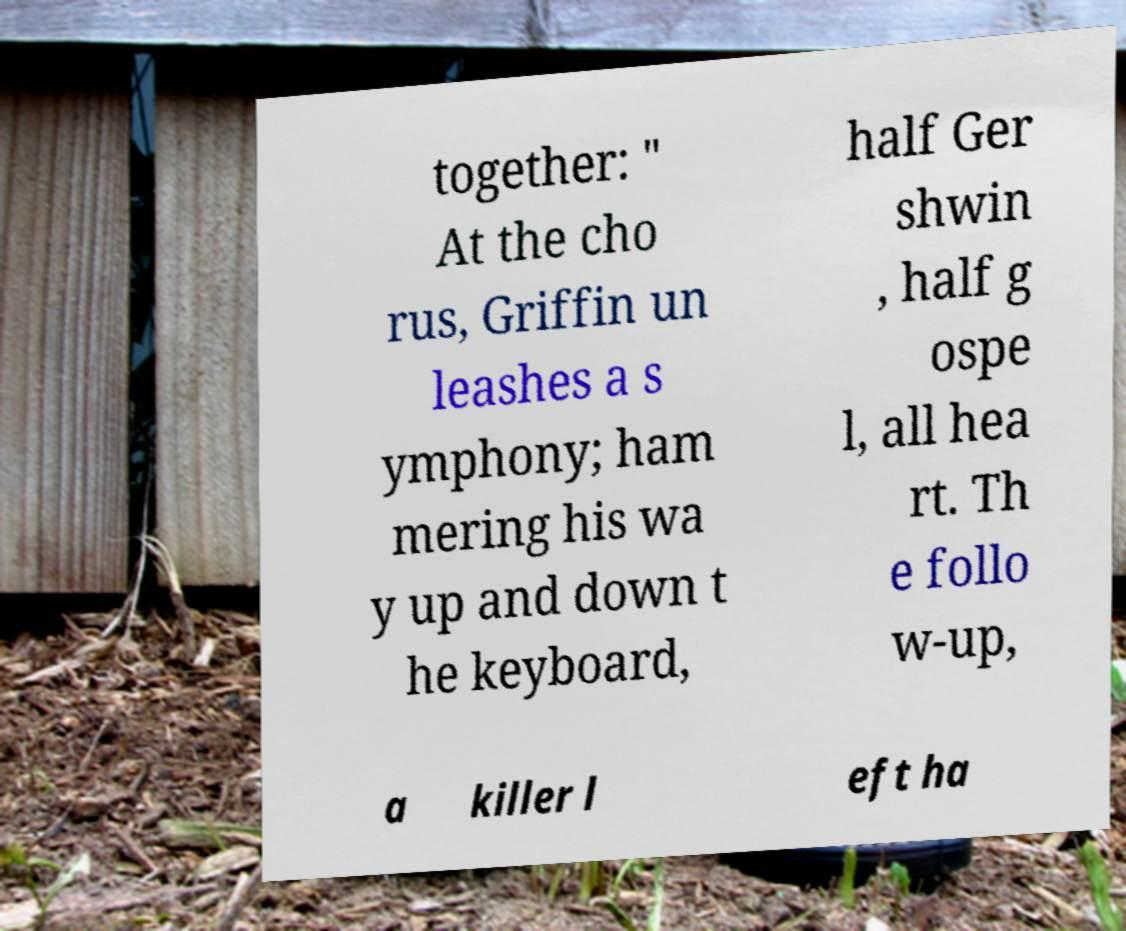Please identify and transcribe the text found in this image. together: " At the cho rus, Griffin un leashes a s ymphony; ham mering his wa y up and down t he keyboard, half Ger shwin , half g ospe l, all hea rt. Th e follo w-up, a killer l eft ha 